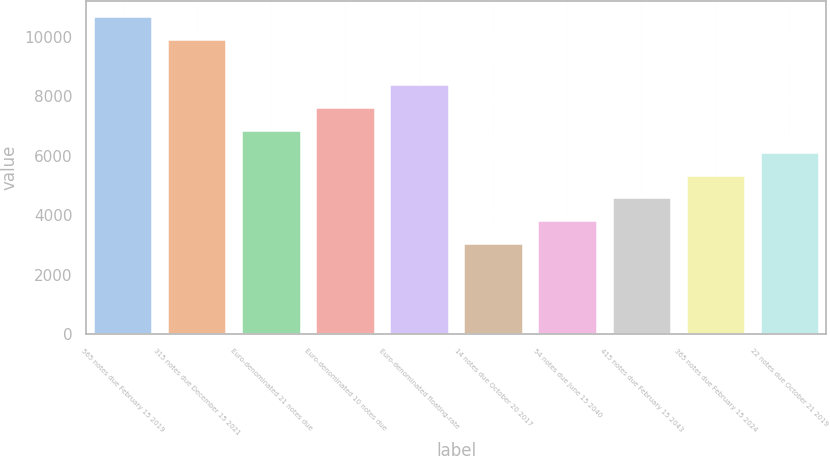Convert chart. <chart><loc_0><loc_0><loc_500><loc_500><bar_chart><fcel>565 notes due February 15 2019<fcel>315 notes due December 15 2021<fcel>Euro-denominated 21 notes due<fcel>Euro-denominated 10 notes due<fcel>Euro-denominated floating-rate<fcel>14 notes due October 20 2017<fcel>54 notes due June 15 2040<fcel>415 notes due February 15 2043<fcel>365 notes due February 15 2024<fcel>22 notes due October 21 2019<nl><fcel>10684.1<fcel>9923.83<fcel>6882.59<fcel>7642.9<fcel>8403.21<fcel>3081.04<fcel>3841.35<fcel>4601.66<fcel>5361.97<fcel>6122.28<nl></chart> 